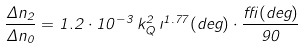Convert formula to latex. <formula><loc_0><loc_0><loc_500><loc_500>\frac { \Delta n _ { 2 } } { \Delta n _ { 0 } } = 1 . 2 \cdot 1 0 ^ { - 3 } \, k _ { Q } ^ { 2 } \, \zeta ^ { 1 . 7 7 } ( d e g ) \cdot \frac { \delta ( d e g ) } { 9 0 }</formula> 